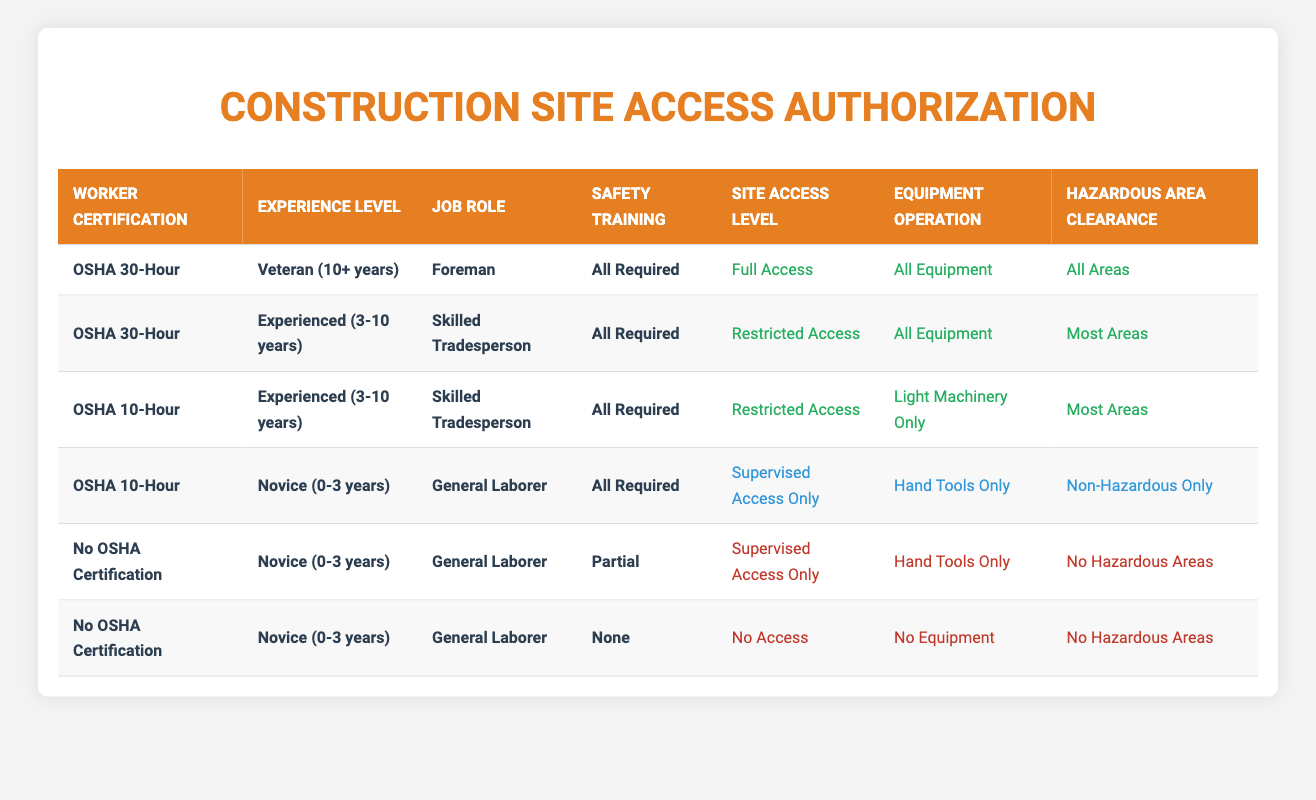What is the site access level for a veteran foreman with OSHA 30-Hour certification? The relevant row shows that a worker with OSHA 30-Hour certification, a veteran experience level of 10+ years, and in the role of foreman is granted "Full Access."
Answer: Full Access How many workers have Restricted Access? There are two rows in the table with "Restricted Access." The first is for an experienced skilled tradesperson with OSHA 30-Hour certification, and the second is for an experienced skilled tradesperson with OSHA 10-Hour certification.
Answer: 2 Is a novice general laborer with no OSHA certification and no training allowed access to the site? The last row shows that a novice general laborer with no OSHA certification and none of the required training is granted "No Access."
Answer: Yes What equipment can an experienced skilled tradesperson with OSHA 10-Hour certification operate? Referring to the third row of the table, an experienced skilled tradesperson with OSHA 10-Hour certification has permission to operate "Light Machinery Only."
Answer: Light Machinery Only If a novice general laborer has completed all required safety training, what is their hazardous area clearance? The relevant row indicates that a novice general laborer who has completed all required safety training can only access "Non-Hazardous Only" areas.
Answer: Non-Hazardous Only How does the site access level compare between a veteran foreman and an experienced skilled tradesperson with OSHA 30-Hour certification? The veteran foreman has "Full Access," whereas the experienced skilled tradesperson has "Restricted Access." Therefore, the foreman has greater access compared to the skilled tradesperson.
Answer: Greater access for foreman What is the primary difference in site access levels between novice general laborers with all required training versus those with partial training and no OSHA certification? The novice with all required training has "Supervised Access Only" while the novice with partial training and no OSHA certification has the same "Supervised Access Only." But the latter grants only "No Hazardous Areas" whereas the former allows "Non-Hazardous Only."
Answer: Similar access levels but different restrictions Is it true that a skilled tradesperson with OSHA 10-Hour certification has access to all areas? By checking the relevant rows, it's clear that a skilled tradesperson with OSHA 10-Hour certification does not have access to all areas; instead, they have "Most Areas."
Answer: No 